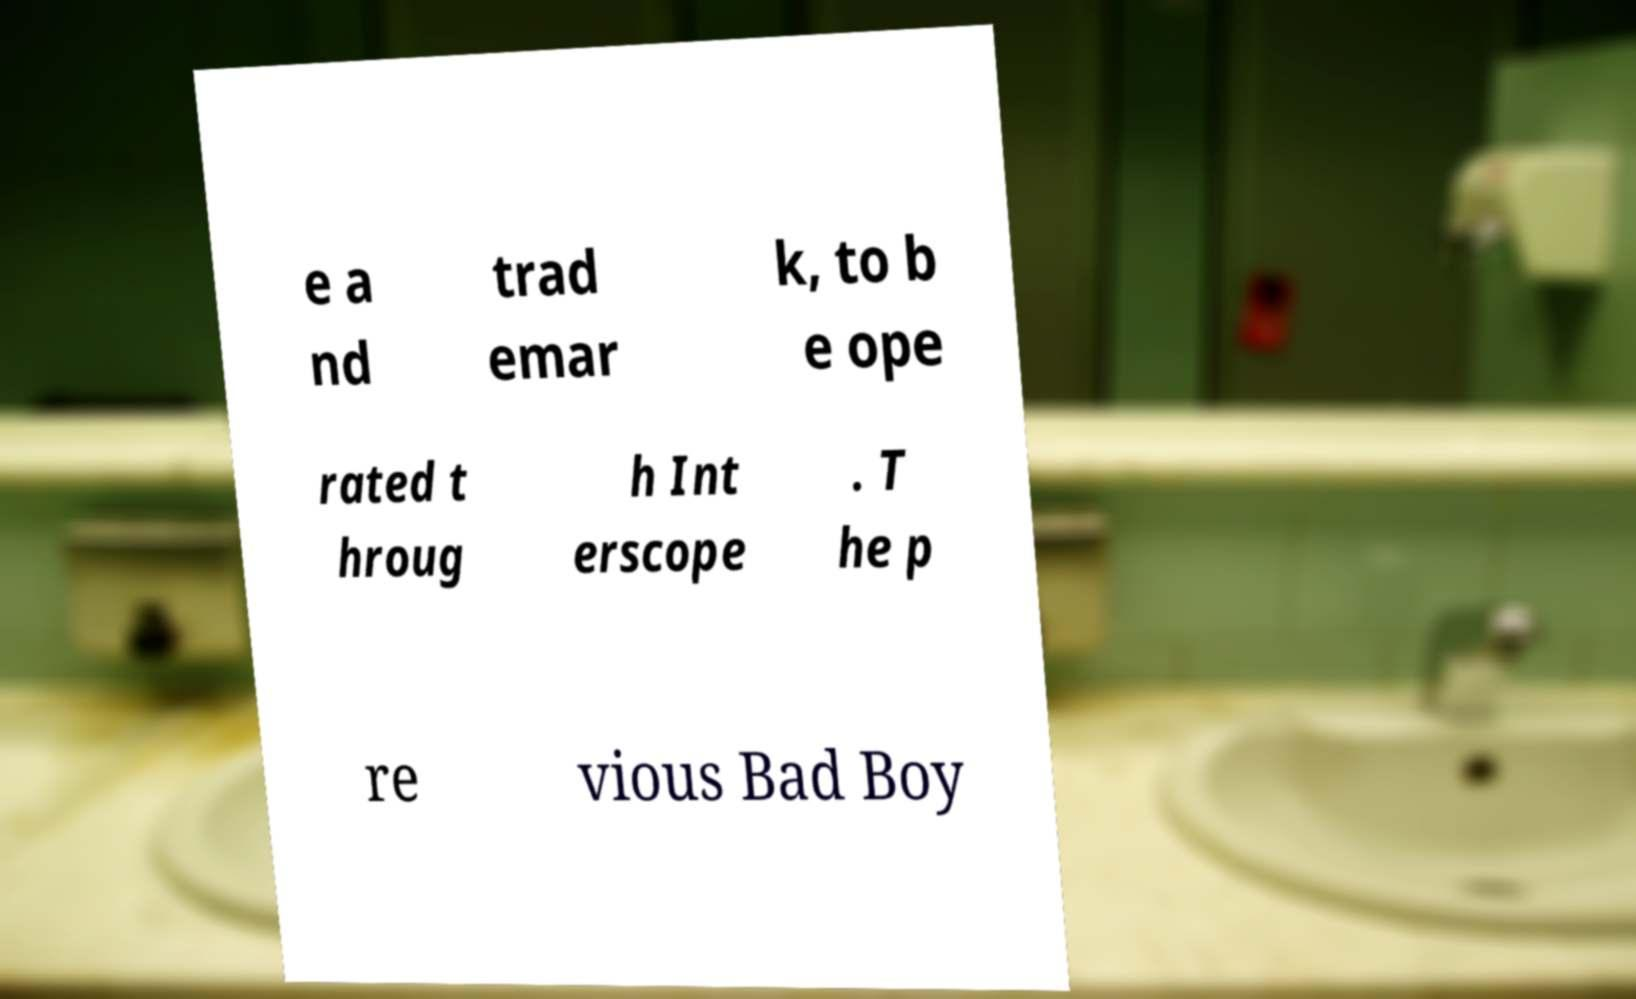Please read and relay the text visible in this image. What does it say? e a nd trad emar k, to b e ope rated t hroug h Int erscope . T he p re vious Bad Boy 